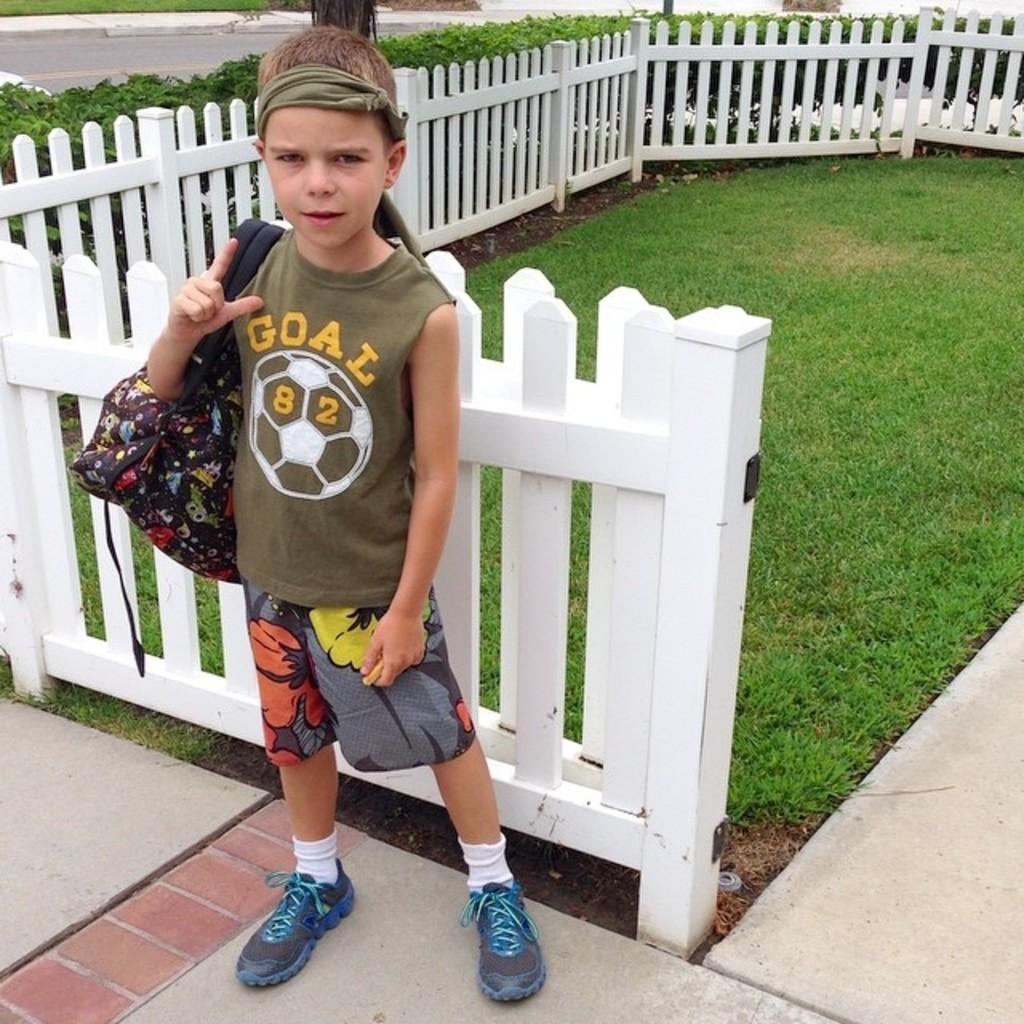In one or two sentences, can you explain what this image depicts? In this picture we can see a boy carrying a bag and standing on a path and at the back of him we can see the grass, fence and in the background we can see the road, plants and some objects. 